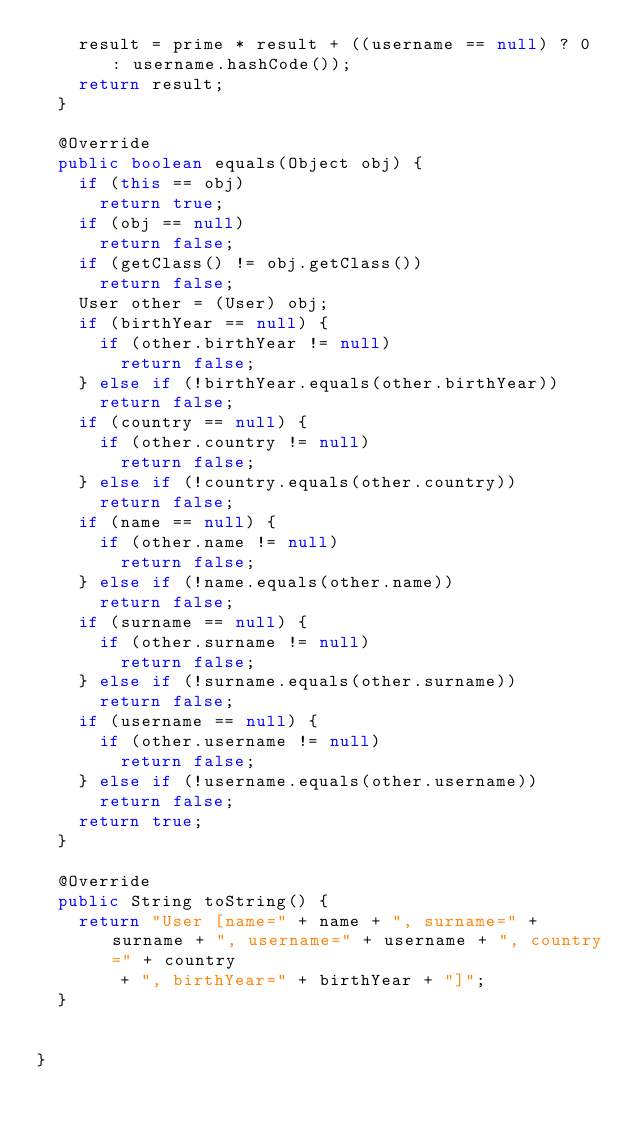<code> <loc_0><loc_0><loc_500><loc_500><_Java_>		result = prime * result + ((username == null) ? 0 : username.hashCode());
		return result;
	}

	@Override
	public boolean equals(Object obj) {
		if (this == obj)
			return true;
		if (obj == null)
			return false;
		if (getClass() != obj.getClass())
			return false;
		User other = (User) obj;
		if (birthYear == null) {
			if (other.birthYear != null)
				return false;
		} else if (!birthYear.equals(other.birthYear))
			return false;
		if (country == null) {
			if (other.country != null)
				return false;
		} else if (!country.equals(other.country))
			return false;
		if (name == null) {
			if (other.name != null)
				return false;
		} else if (!name.equals(other.name))
			return false;
		if (surname == null) {
			if (other.surname != null)
				return false;
		} else if (!surname.equals(other.surname))
			return false;
		if (username == null) {
			if (other.username != null)
				return false;
		} else if (!username.equals(other.username))
			return false;
		return true;
	}

	@Override
	public String toString() {
		return "User [name=" + name + ", surname=" + surname + ", username=" + username + ", country=" + country
				+ ", birthYear=" + birthYear + "]";
	}
	
	
}
</code> 